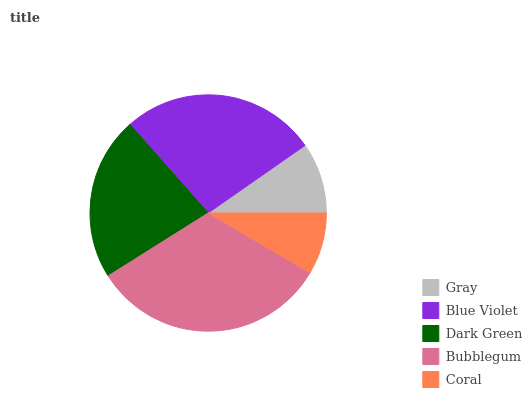Is Coral the minimum?
Answer yes or no. Yes. Is Bubblegum the maximum?
Answer yes or no. Yes. Is Blue Violet the minimum?
Answer yes or no. No. Is Blue Violet the maximum?
Answer yes or no. No. Is Blue Violet greater than Gray?
Answer yes or no. Yes. Is Gray less than Blue Violet?
Answer yes or no. Yes. Is Gray greater than Blue Violet?
Answer yes or no. No. Is Blue Violet less than Gray?
Answer yes or no. No. Is Dark Green the high median?
Answer yes or no. Yes. Is Dark Green the low median?
Answer yes or no. Yes. Is Gray the high median?
Answer yes or no. No. Is Blue Violet the low median?
Answer yes or no. No. 